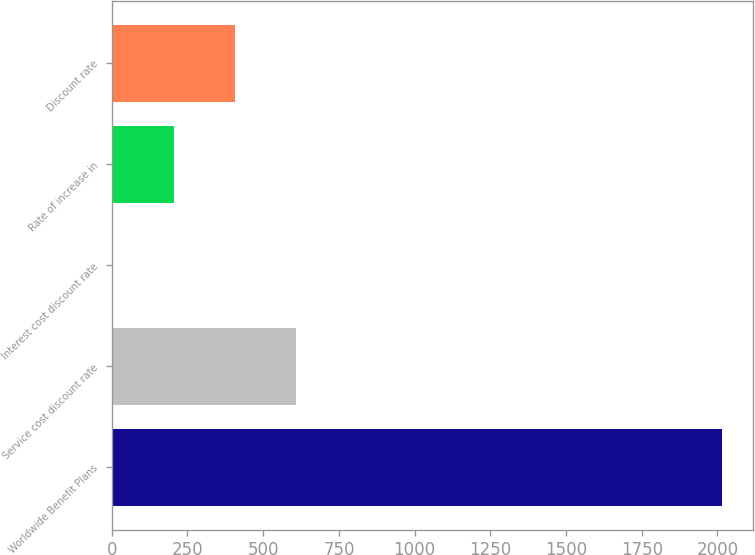<chart> <loc_0><loc_0><loc_500><loc_500><bar_chart><fcel>Worldwide Benefit Plans<fcel>Service cost discount rate<fcel>Interest cost discount rate<fcel>Rate of increase in<fcel>Discount rate<nl><fcel>2016<fcel>607.67<fcel>4.1<fcel>205.29<fcel>406.48<nl></chart> 